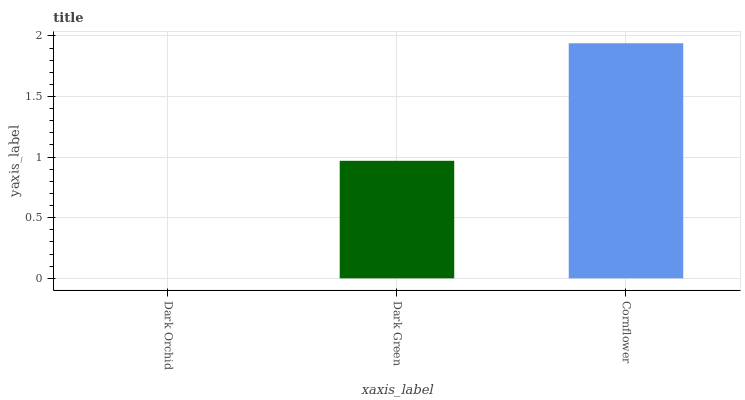Is Dark Orchid the minimum?
Answer yes or no. Yes. Is Cornflower the maximum?
Answer yes or no. Yes. Is Dark Green the minimum?
Answer yes or no. No. Is Dark Green the maximum?
Answer yes or no. No. Is Dark Green greater than Dark Orchid?
Answer yes or no. Yes. Is Dark Orchid less than Dark Green?
Answer yes or no. Yes. Is Dark Orchid greater than Dark Green?
Answer yes or no. No. Is Dark Green less than Dark Orchid?
Answer yes or no. No. Is Dark Green the high median?
Answer yes or no. Yes. Is Dark Green the low median?
Answer yes or no. Yes. Is Dark Orchid the high median?
Answer yes or no. No. Is Dark Orchid the low median?
Answer yes or no. No. 